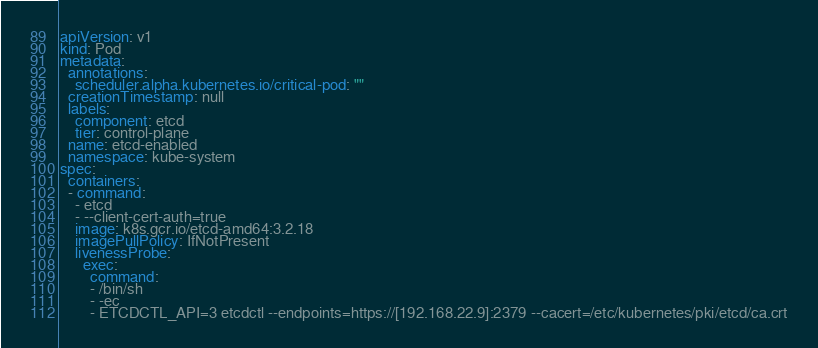<code> <loc_0><loc_0><loc_500><loc_500><_YAML_>apiVersion: v1
kind: Pod
metadata:
  annotations:
    scheduler.alpha.kubernetes.io/critical-pod: ""
  creationTimestamp: null
  labels:
    component: etcd
    tier: control-plane
  name: etcd-enabled
  namespace: kube-system
spec:
  containers:
  - command:
    - etcd
    - --client-cert-auth=true
    image: k8s.gcr.io/etcd-amd64:3.2.18
    imagePullPolicy: IfNotPresent
    livenessProbe:
      exec:
        command:
        - /bin/sh
        - -ec
        - ETCDCTL_API=3 etcdctl --endpoints=https://[192.168.22.9]:2379 --cacert=/etc/kubernetes/pki/etcd/ca.crt</code> 